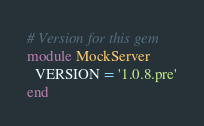Convert code to text. <code><loc_0><loc_0><loc_500><loc_500><_Ruby_># Version for this gem
module MockServer
  VERSION = '1.0.8.pre'
end
</code> 